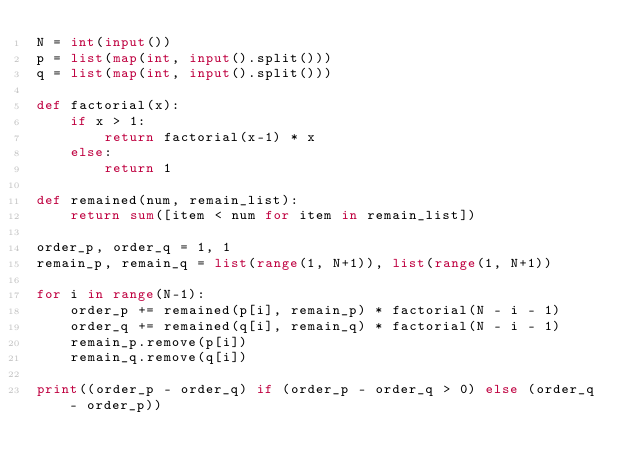<code> <loc_0><loc_0><loc_500><loc_500><_Python_>N = int(input())
p = list(map(int, input().split()))
q = list(map(int, input().split()))

def factorial(x):
    if x > 1:
        return factorial(x-1) * x
    else:
        return 1

def remained(num, remain_list):
    return sum([item < num for item in remain_list])

order_p, order_q = 1, 1
remain_p, remain_q = list(range(1, N+1)), list(range(1, N+1))

for i in range(N-1):
    order_p += remained(p[i], remain_p) * factorial(N - i - 1)
    order_q += remained(q[i], remain_q) * factorial(N - i - 1)
    remain_p.remove(p[i])
    remain_q.remove(q[i])

print((order_p - order_q) if (order_p - order_q > 0) else (order_q - order_p))</code> 